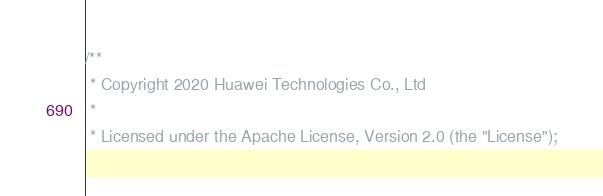Convert code to text. <code><loc_0><loc_0><loc_500><loc_500><_C_>/**
 * Copyright 2020 Huawei Technologies Co., Ltd
 *
 * Licensed under the Apache License, Version 2.0 (the "License");</code> 